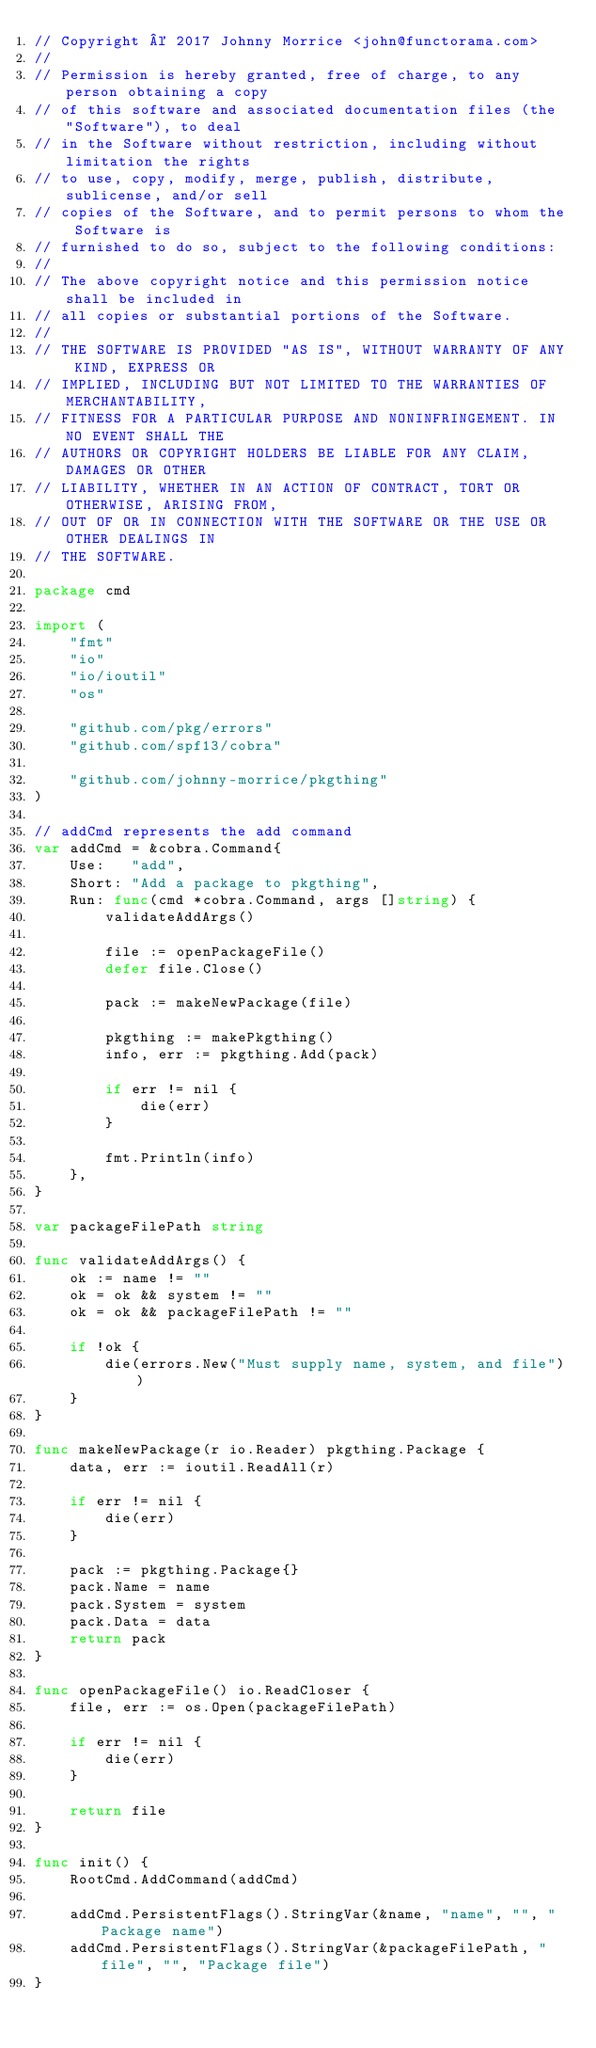<code> <loc_0><loc_0><loc_500><loc_500><_Go_>// Copyright © 2017 Johnny Morrice <john@functorama.com>
//
// Permission is hereby granted, free of charge, to any person obtaining a copy
// of this software and associated documentation files (the "Software"), to deal
// in the Software without restriction, including without limitation the rights
// to use, copy, modify, merge, publish, distribute, sublicense, and/or sell
// copies of the Software, and to permit persons to whom the Software is
// furnished to do so, subject to the following conditions:
//
// The above copyright notice and this permission notice shall be included in
// all copies or substantial portions of the Software.
//
// THE SOFTWARE IS PROVIDED "AS IS", WITHOUT WARRANTY OF ANY KIND, EXPRESS OR
// IMPLIED, INCLUDING BUT NOT LIMITED TO THE WARRANTIES OF MERCHANTABILITY,
// FITNESS FOR A PARTICULAR PURPOSE AND NONINFRINGEMENT. IN NO EVENT SHALL THE
// AUTHORS OR COPYRIGHT HOLDERS BE LIABLE FOR ANY CLAIM, DAMAGES OR OTHER
// LIABILITY, WHETHER IN AN ACTION OF CONTRACT, TORT OR OTHERWISE, ARISING FROM,
// OUT OF OR IN CONNECTION WITH THE SOFTWARE OR THE USE OR OTHER DEALINGS IN
// THE SOFTWARE.

package cmd

import (
	"fmt"
	"io"
	"io/ioutil"
	"os"

	"github.com/pkg/errors"
	"github.com/spf13/cobra"

	"github.com/johnny-morrice/pkgthing"
)

// addCmd represents the add command
var addCmd = &cobra.Command{
	Use:   "add",
	Short: "Add a package to pkgthing",
	Run: func(cmd *cobra.Command, args []string) {
		validateAddArgs()

		file := openPackageFile()
		defer file.Close()

		pack := makeNewPackage(file)

		pkgthing := makePkgthing()
		info, err := pkgthing.Add(pack)

		if err != nil {
			die(err)
		}

		fmt.Println(info)
	},
}

var packageFilePath string

func validateAddArgs() {
	ok := name != ""
	ok = ok && system != ""
	ok = ok && packageFilePath != ""

	if !ok {
		die(errors.New("Must supply name, system, and file"))
	}
}

func makeNewPackage(r io.Reader) pkgthing.Package {
	data, err := ioutil.ReadAll(r)

	if err != nil {
		die(err)
	}

	pack := pkgthing.Package{}
	pack.Name = name
	pack.System = system
	pack.Data = data
	return pack
}

func openPackageFile() io.ReadCloser {
	file, err := os.Open(packageFilePath)

	if err != nil {
		die(err)
	}

	return file
}

func init() {
	RootCmd.AddCommand(addCmd)

	addCmd.PersistentFlags().StringVar(&name, "name", "", "Package name")
	addCmd.PersistentFlags().StringVar(&packageFilePath, "file", "", "Package file")
}
</code> 